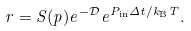Convert formula to latex. <formula><loc_0><loc_0><loc_500><loc_500>r = S ( p ) e ^ { - \mathcal { D } } e ^ { P _ { \text {in} } \Delta t / k _ { \text {B} } T } .</formula> 